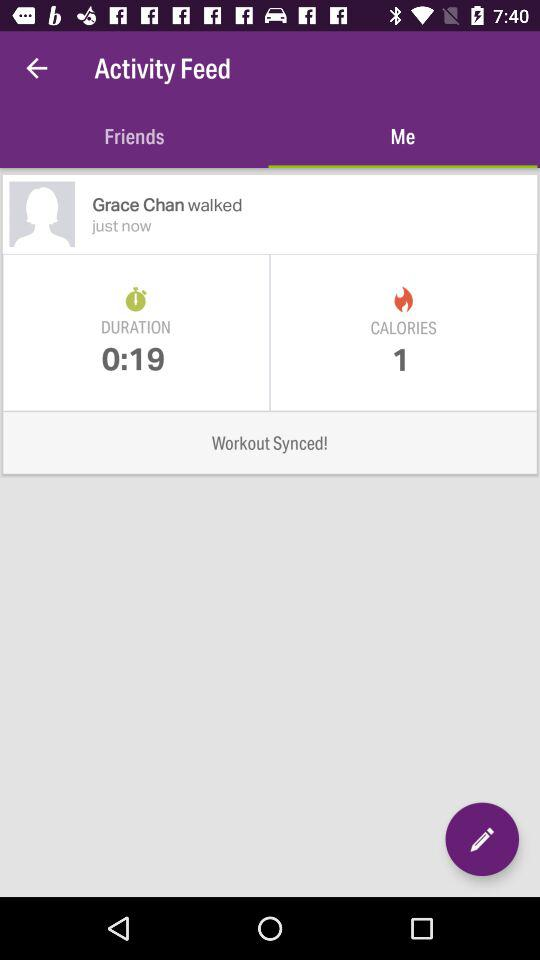How many calories did Grace burn?
Answer the question using a single word or phrase. 1 